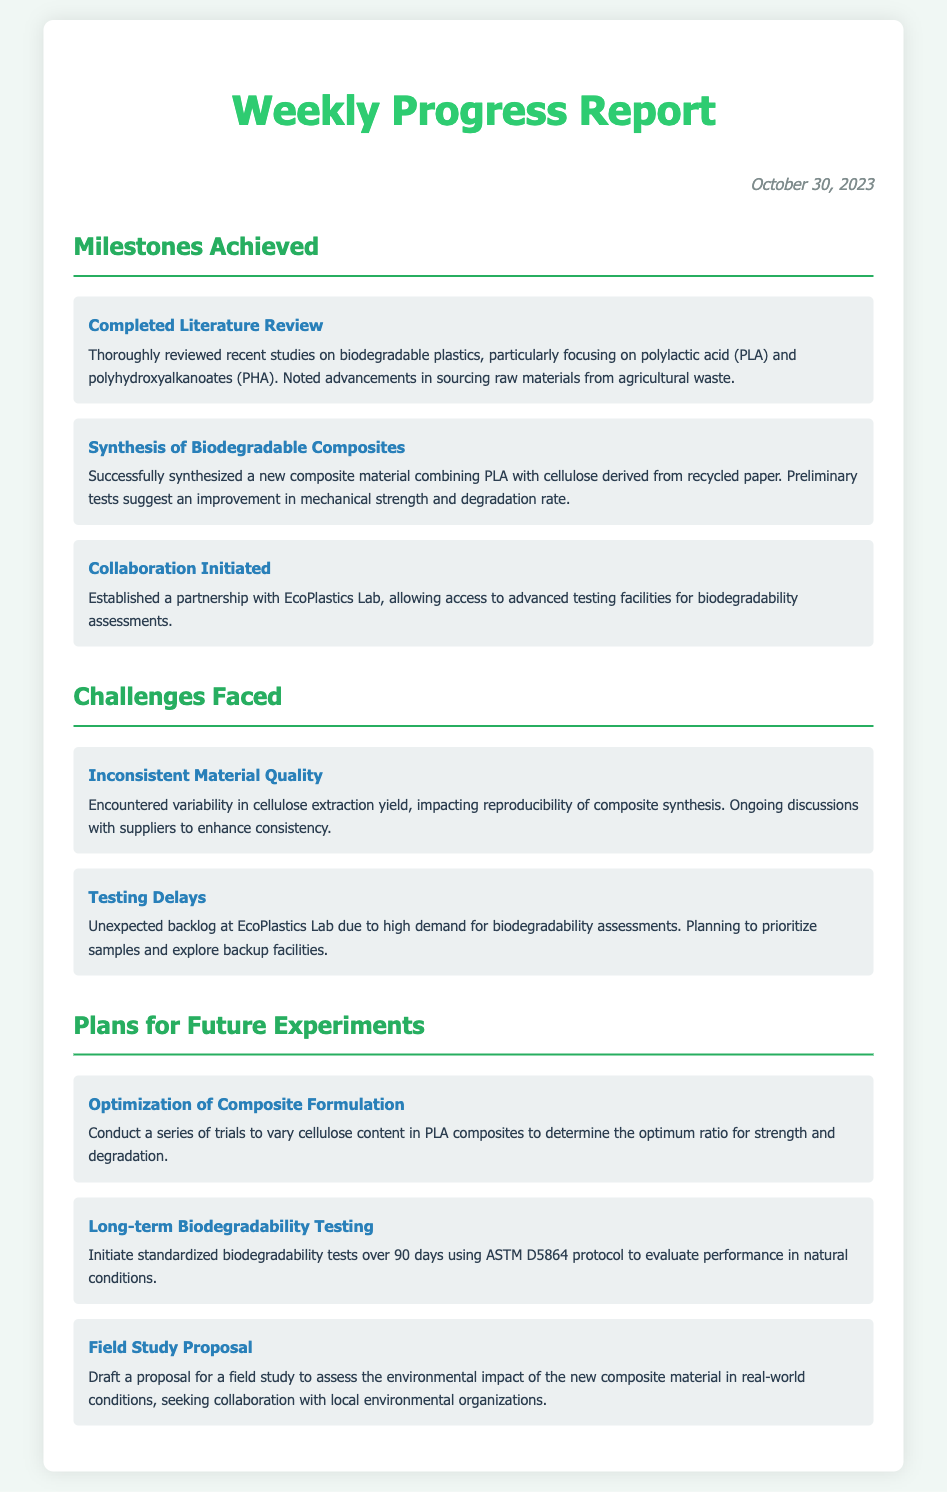What date is the report from? The date is provided at the top of the report as the date the memo was created.
Answer: October 30, 2023 What is the first milestone achieved? The milestones section lists accomplishments, starting with the first one identified specifically.
Answer: Completed Literature Review What new composite material was synthesized? Details in the milestones section specify the materials involved in the synthesis mentioned.
Answer: PLA with cellulose derived from recycled paper What challenge relates to material quality? The challenges section mentions specific issues faced during the research, one of which is linked to material quality.
Answer: Inconsistent Material Quality What is the plan regarding the composite formulation? Plans for future experiments outline goals, including maximizing the effectiveness of the composite material.
Answer: Optimization of Composite Formulation How long will the biodegradability testing last? The proposal for testing is stated clearly in the corresponding plans section regarding its duration.
Answer: 90 days Which lab was partnered with for testing? The collaboration section offers the name of the lab that will assist with testing in the project.
Answer: EcoPlastics Lab What is a challenge related to testing? A specific issue faced regarding the testing process is highlighted under challenges, indicating a common problem.
Answer: Testing Delays 